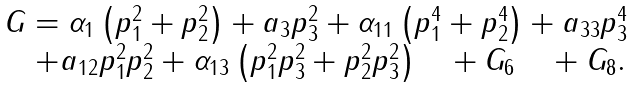<formula> <loc_0><loc_0><loc_500><loc_500>\begin{array} { l } G = \alpha _ { 1 } \left ( { p _ { 1 } ^ { 2 } + p _ { 2 } ^ { 2 } } \right ) + a _ { 3 } p _ { 3 } ^ { 2 } + \alpha _ { 1 1 } \left ( { p _ { 1 } ^ { 4 } + p _ { 2 } ^ { 4 } } \right ) + a _ { 3 3 } p _ { 3 } ^ { 4 } \\ \quad + a _ { 1 2 } p _ { 1 } ^ { 2 } p _ { 2 } ^ { 2 } + \alpha _ { 1 3 } \left ( { p _ { 1 } ^ { 2 } p _ { 3 } ^ { 2 } + p _ { 2 } ^ { 2 } p _ { 3 } ^ { 2 } } \right ) \quad + G _ { 6 } \quad + G _ { 8 } . \\ \end{array}</formula> 